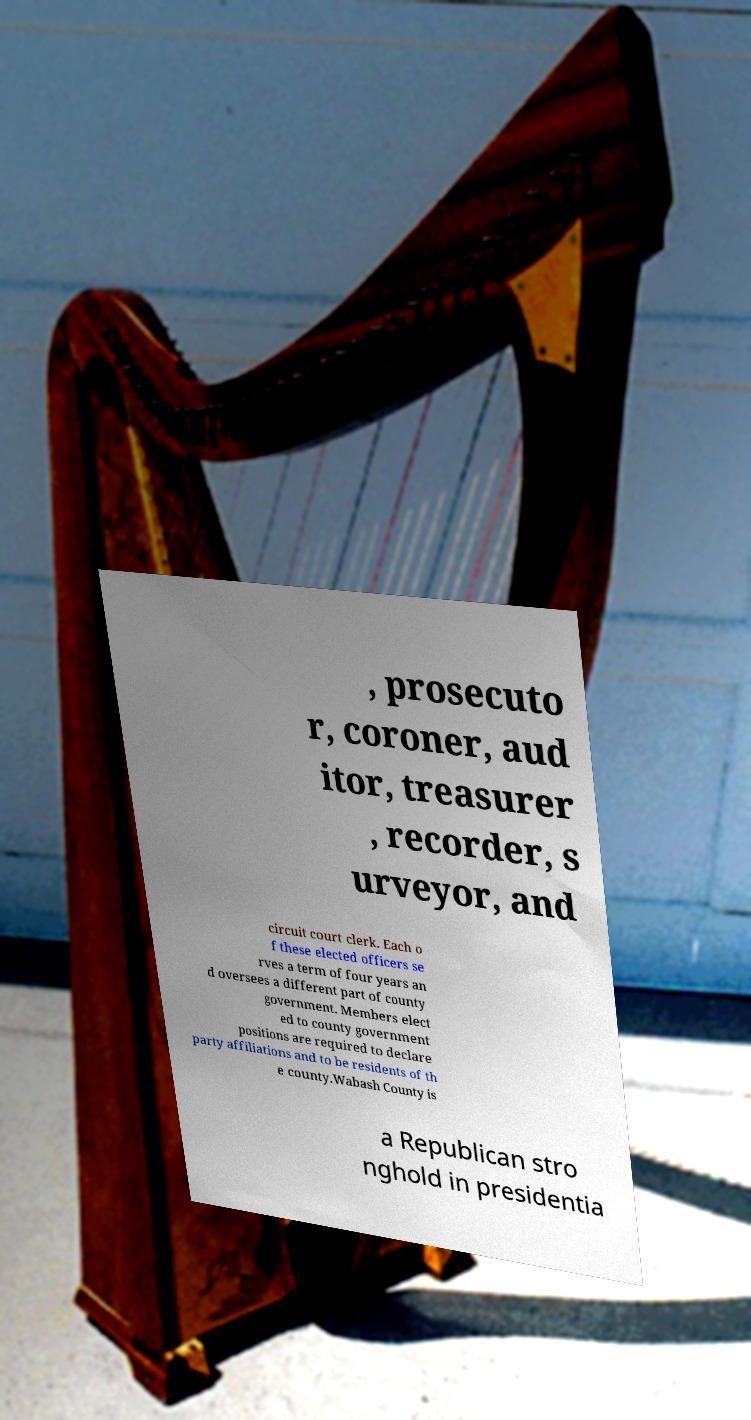Can you accurately transcribe the text from the provided image for me? , prosecuto r, coroner, aud itor, treasurer , recorder, s urveyor, and circuit court clerk. Each o f these elected officers se rves a term of four years an d oversees a different part of county government. Members elect ed to county government positions are required to declare party affiliations and to be residents of th e county.Wabash County is a Republican stro nghold in presidentia 